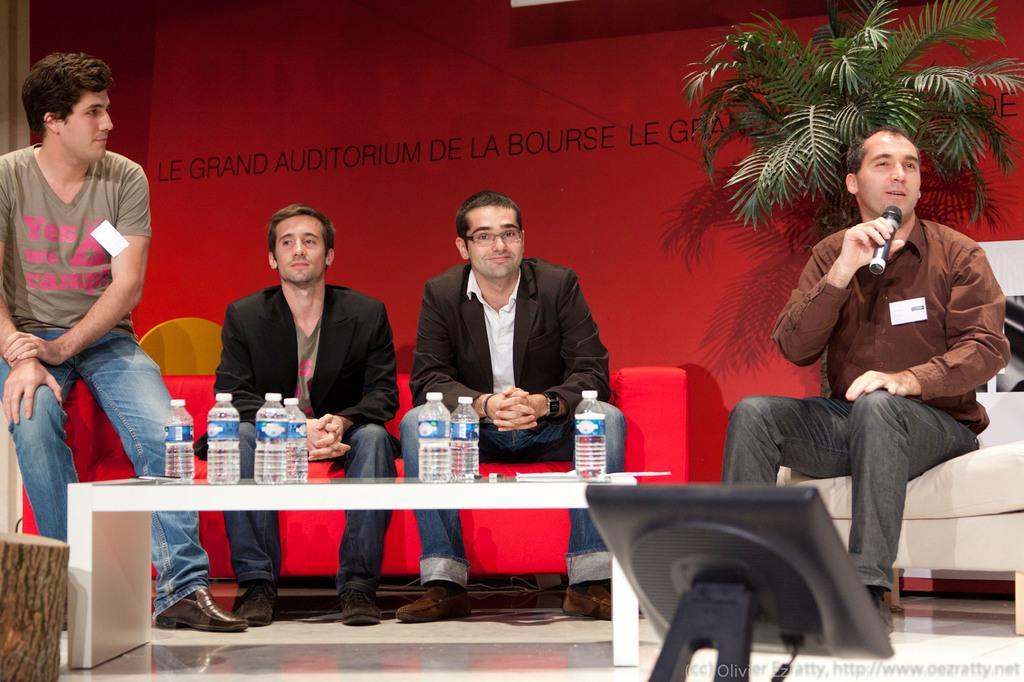In one or two sentences, can you explain what this image depicts? In this image there are 4 persons sitting in a couch, 1 person holding a microphone and talking , and on table there are water bottles, light, and the back ground there is wall or hoarding,a plant. 